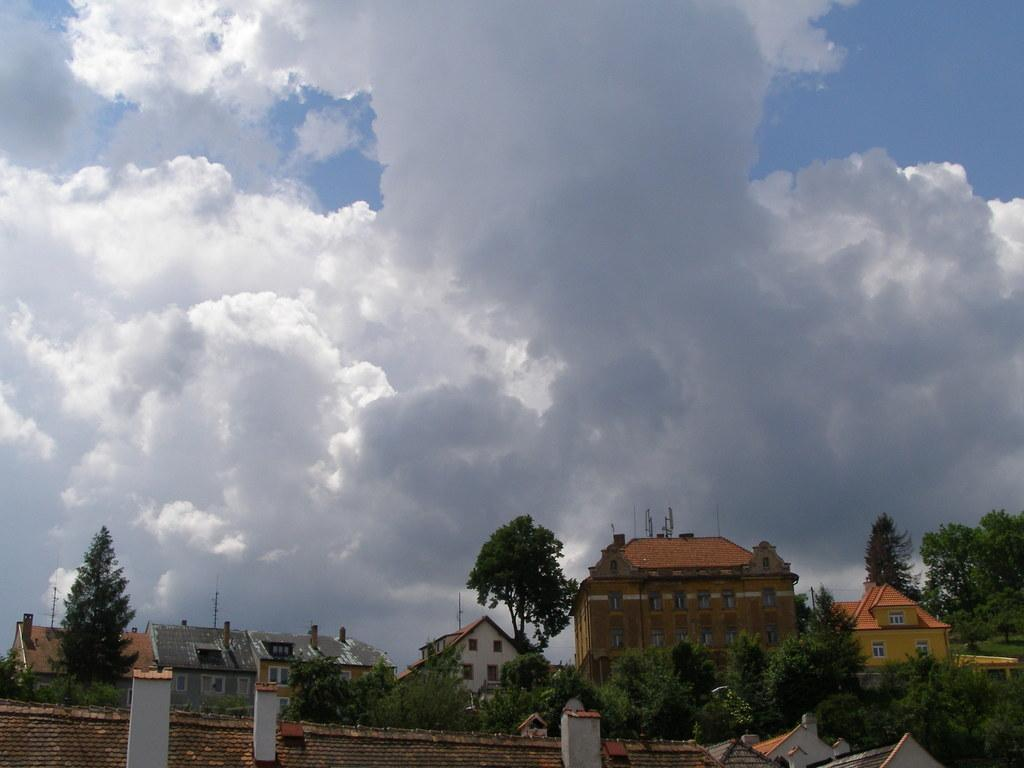What can be found at the bottom of the image? There are trees, buildings, and current poles at the bottom of the image. What is the condition of the sky in the image? The sky is cloudy in the image. Where is the library located in the image? There is no library mentioned or visible in the image. What type of box can be seen near the current poles? There is no box present near the current poles in the image. 